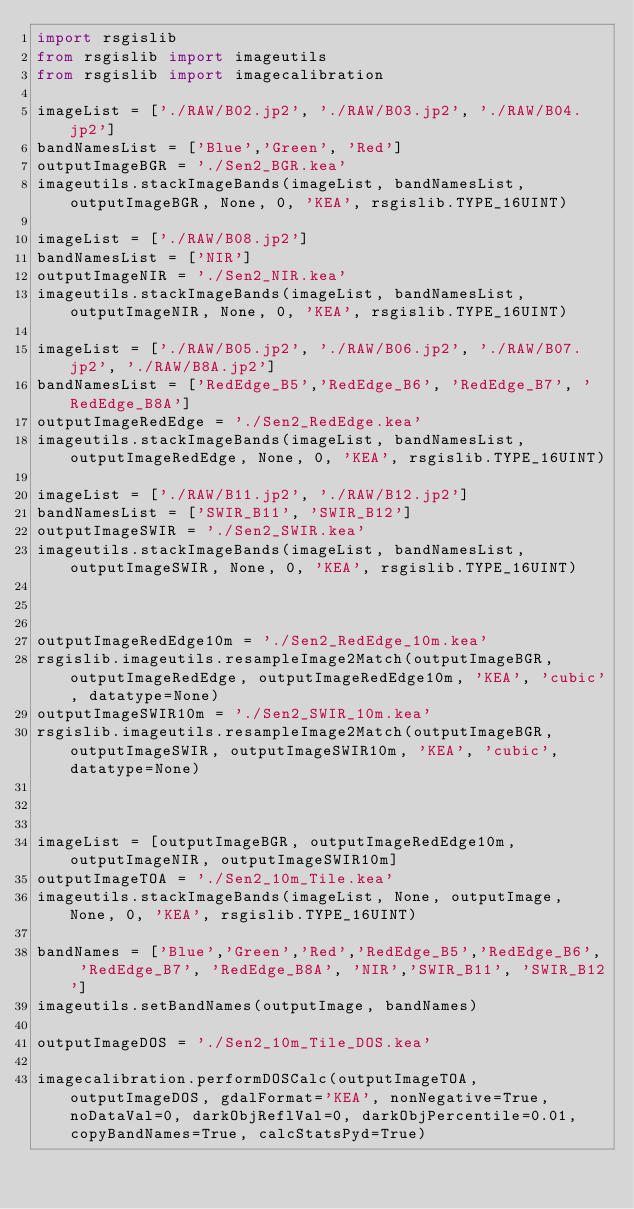Convert code to text. <code><loc_0><loc_0><loc_500><loc_500><_Python_>import rsgislib
from rsgislib import imageutils
from rsgislib import imagecalibration

imageList = ['./RAW/B02.jp2', './RAW/B03.jp2', './RAW/B04.jp2']
bandNamesList = ['Blue','Green', 'Red']
outputImageBGR = './Sen2_BGR.kea'
imageutils.stackImageBands(imageList, bandNamesList, outputImageBGR, None, 0, 'KEA', rsgislib.TYPE_16UINT)

imageList = ['./RAW/B08.jp2']
bandNamesList = ['NIR']
outputImageNIR = './Sen2_NIR.kea'
imageutils.stackImageBands(imageList, bandNamesList, outputImageNIR, None, 0, 'KEA', rsgislib.TYPE_16UINT)

imageList = ['./RAW/B05.jp2', './RAW/B06.jp2', './RAW/B07.jp2', './RAW/B8A.jp2']
bandNamesList = ['RedEdge_B5','RedEdge_B6', 'RedEdge_B7', 'RedEdge_B8A']
outputImageRedEdge = './Sen2_RedEdge.kea'
imageutils.stackImageBands(imageList, bandNamesList, outputImageRedEdge, None, 0, 'KEA', rsgislib.TYPE_16UINT)

imageList = ['./RAW/B11.jp2', './RAW/B12.jp2']
bandNamesList = ['SWIR_B11', 'SWIR_B12']
outputImageSWIR = './Sen2_SWIR.kea'
imageutils.stackImageBands(imageList, bandNamesList, outputImageSWIR, None, 0, 'KEA', rsgislib.TYPE_16UINT)



outputImageRedEdge10m = './Sen2_RedEdge_10m.kea'
rsgislib.imageutils.resampleImage2Match(outputImageBGR, outputImageRedEdge, outputImageRedEdge10m, 'KEA', 'cubic', datatype=None)
outputImageSWIR10m = './Sen2_SWIR_10m.kea'
rsgislib.imageutils.resampleImage2Match(outputImageBGR, outputImageSWIR, outputImageSWIR10m, 'KEA', 'cubic', datatype=None)



imageList = [outputImageBGR, outputImageRedEdge10m, outputImageNIR, outputImageSWIR10m]
outputImageTOA = './Sen2_10m_Tile.kea'
imageutils.stackImageBands(imageList, None, outputImage, None, 0, 'KEA', rsgislib.TYPE_16UINT)

bandNames = ['Blue','Green','Red','RedEdge_B5','RedEdge_B6', 'RedEdge_B7', 'RedEdge_B8A', 'NIR','SWIR_B11', 'SWIR_B12']
imageutils.setBandNames(outputImage, bandNames)

outputImageDOS = './Sen2_10m_Tile_DOS.kea'

imagecalibration.performDOSCalc(outputImageTOA, outputImageDOS, gdalFormat='KEA', nonNegative=True, noDataVal=0, darkObjReflVal=0, darkObjPercentile=0.01, copyBandNames=True, calcStatsPyd=True)



</code> 